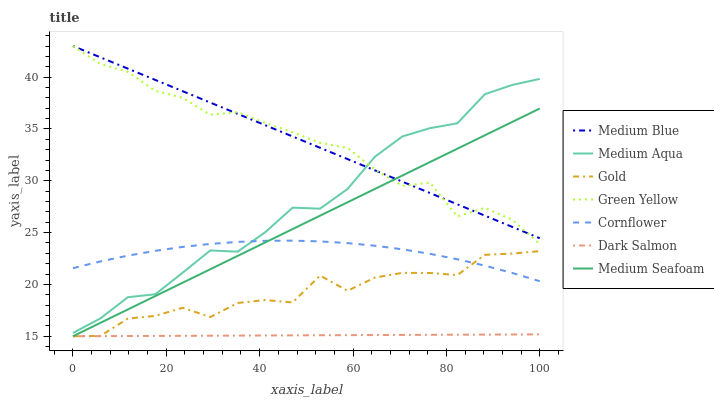Does Dark Salmon have the minimum area under the curve?
Answer yes or no. Yes. Does Medium Blue have the maximum area under the curve?
Answer yes or no. Yes. Does Gold have the minimum area under the curve?
Answer yes or no. No. Does Gold have the maximum area under the curve?
Answer yes or no. No. Is Dark Salmon the smoothest?
Answer yes or no. Yes. Is Gold the roughest?
Answer yes or no. Yes. Is Medium Blue the smoothest?
Answer yes or no. No. Is Medium Blue the roughest?
Answer yes or no. No. Does Medium Blue have the lowest value?
Answer yes or no. No. Does Green Yellow have the highest value?
Answer yes or no. Yes. Does Gold have the highest value?
Answer yes or no. No. Is Gold less than Medium Blue?
Answer yes or no. Yes. Is Medium Aqua greater than Medium Seafoam?
Answer yes or no. Yes. Does Medium Blue intersect Green Yellow?
Answer yes or no. Yes. Is Medium Blue less than Green Yellow?
Answer yes or no. No. Is Medium Blue greater than Green Yellow?
Answer yes or no. No. Does Gold intersect Medium Blue?
Answer yes or no. No. 